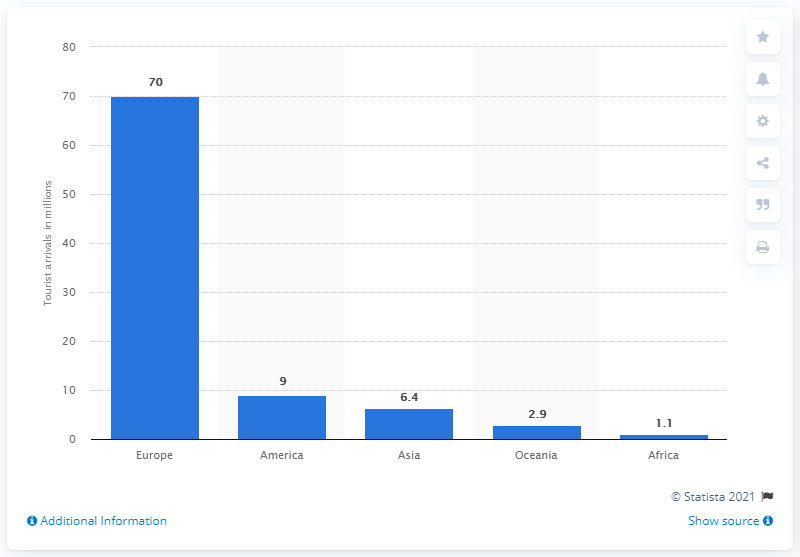Specify some key components in this picture. In 2018, a total of 70 tourists from Europe visited France. The vast majority of tourists who traveled to France came from Europe. 